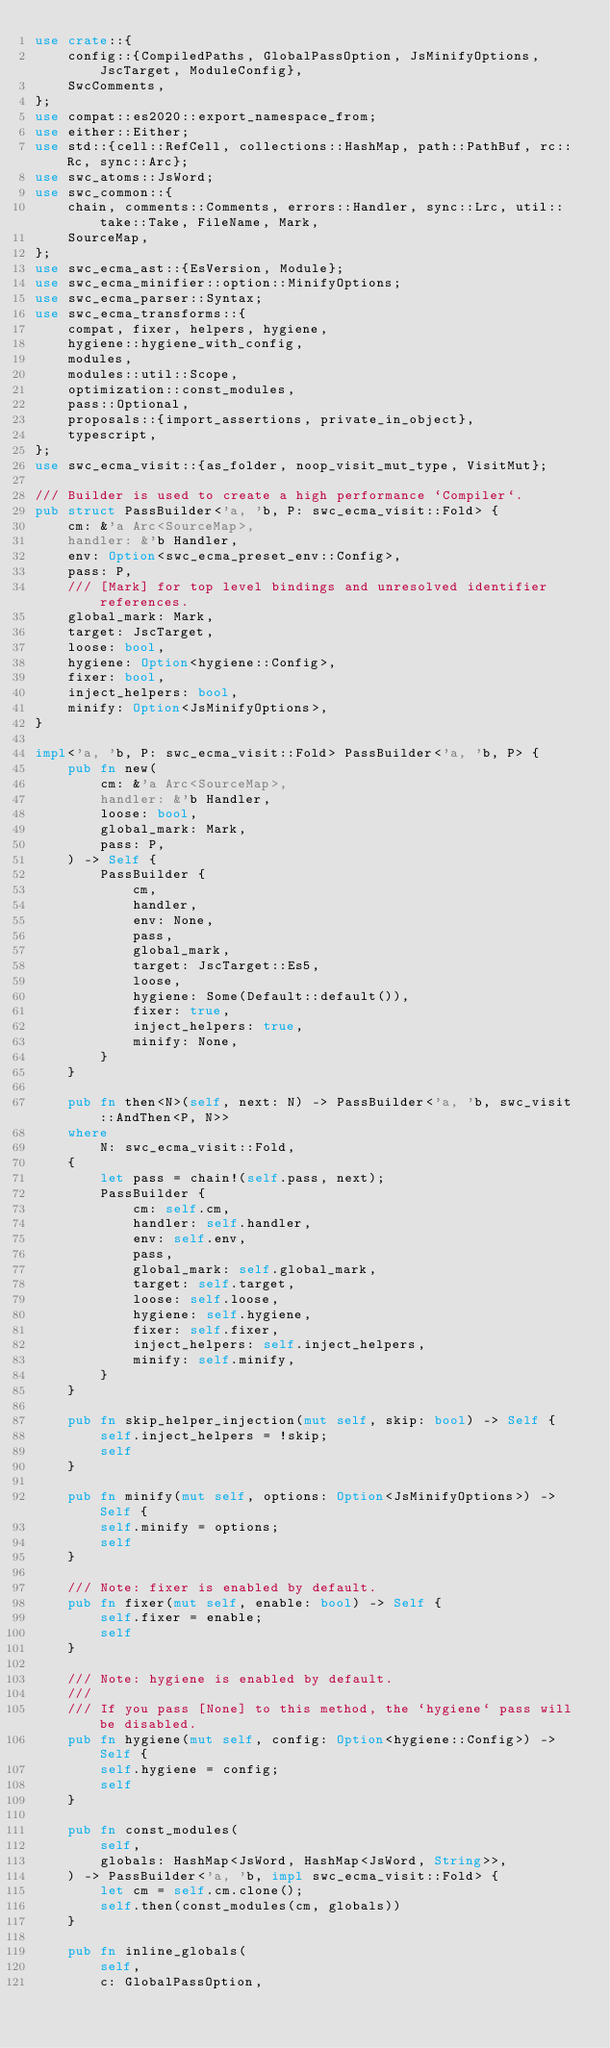<code> <loc_0><loc_0><loc_500><loc_500><_Rust_>use crate::{
    config::{CompiledPaths, GlobalPassOption, JsMinifyOptions, JscTarget, ModuleConfig},
    SwcComments,
};
use compat::es2020::export_namespace_from;
use either::Either;
use std::{cell::RefCell, collections::HashMap, path::PathBuf, rc::Rc, sync::Arc};
use swc_atoms::JsWord;
use swc_common::{
    chain, comments::Comments, errors::Handler, sync::Lrc, util::take::Take, FileName, Mark,
    SourceMap,
};
use swc_ecma_ast::{EsVersion, Module};
use swc_ecma_minifier::option::MinifyOptions;
use swc_ecma_parser::Syntax;
use swc_ecma_transforms::{
    compat, fixer, helpers, hygiene,
    hygiene::hygiene_with_config,
    modules,
    modules::util::Scope,
    optimization::const_modules,
    pass::Optional,
    proposals::{import_assertions, private_in_object},
    typescript,
};
use swc_ecma_visit::{as_folder, noop_visit_mut_type, VisitMut};

/// Builder is used to create a high performance `Compiler`.
pub struct PassBuilder<'a, 'b, P: swc_ecma_visit::Fold> {
    cm: &'a Arc<SourceMap>,
    handler: &'b Handler,
    env: Option<swc_ecma_preset_env::Config>,
    pass: P,
    /// [Mark] for top level bindings and unresolved identifier references.
    global_mark: Mark,
    target: JscTarget,
    loose: bool,
    hygiene: Option<hygiene::Config>,
    fixer: bool,
    inject_helpers: bool,
    minify: Option<JsMinifyOptions>,
}

impl<'a, 'b, P: swc_ecma_visit::Fold> PassBuilder<'a, 'b, P> {
    pub fn new(
        cm: &'a Arc<SourceMap>,
        handler: &'b Handler,
        loose: bool,
        global_mark: Mark,
        pass: P,
    ) -> Self {
        PassBuilder {
            cm,
            handler,
            env: None,
            pass,
            global_mark,
            target: JscTarget::Es5,
            loose,
            hygiene: Some(Default::default()),
            fixer: true,
            inject_helpers: true,
            minify: None,
        }
    }

    pub fn then<N>(self, next: N) -> PassBuilder<'a, 'b, swc_visit::AndThen<P, N>>
    where
        N: swc_ecma_visit::Fold,
    {
        let pass = chain!(self.pass, next);
        PassBuilder {
            cm: self.cm,
            handler: self.handler,
            env: self.env,
            pass,
            global_mark: self.global_mark,
            target: self.target,
            loose: self.loose,
            hygiene: self.hygiene,
            fixer: self.fixer,
            inject_helpers: self.inject_helpers,
            minify: self.minify,
        }
    }

    pub fn skip_helper_injection(mut self, skip: bool) -> Self {
        self.inject_helpers = !skip;
        self
    }

    pub fn minify(mut self, options: Option<JsMinifyOptions>) -> Self {
        self.minify = options;
        self
    }

    /// Note: fixer is enabled by default.
    pub fn fixer(mut self, enable: bool) -> Self {
        self.fixer = enable;
        self
    }

    /// Note: hygiene is enabled by default.
    ///
    /// If you pass [None] to this method, the `hygiene` pass will be disabled.
    pub fn hygiene(mut self, config: Option<hygiene::Config>) -> Self {
        self.hygiene = config;
        self
    }

    pub fn const_modules(
        self,
        globals: HashMap<JsWord, HashMap<JsWord, String>>,
    ) -> PassBuilder<'a, 'b, impl swc_ecma_visit::Fold> {
        let cm = self.cm.clone();
        self.then(const_modules(cm, globals))
    }

    pub fn inline_globals(
        self,
        c: GlobalPassOption,</code> 